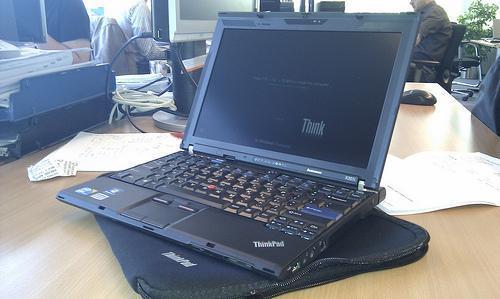How many laptops are there?
Give a very brief answer. 1. 